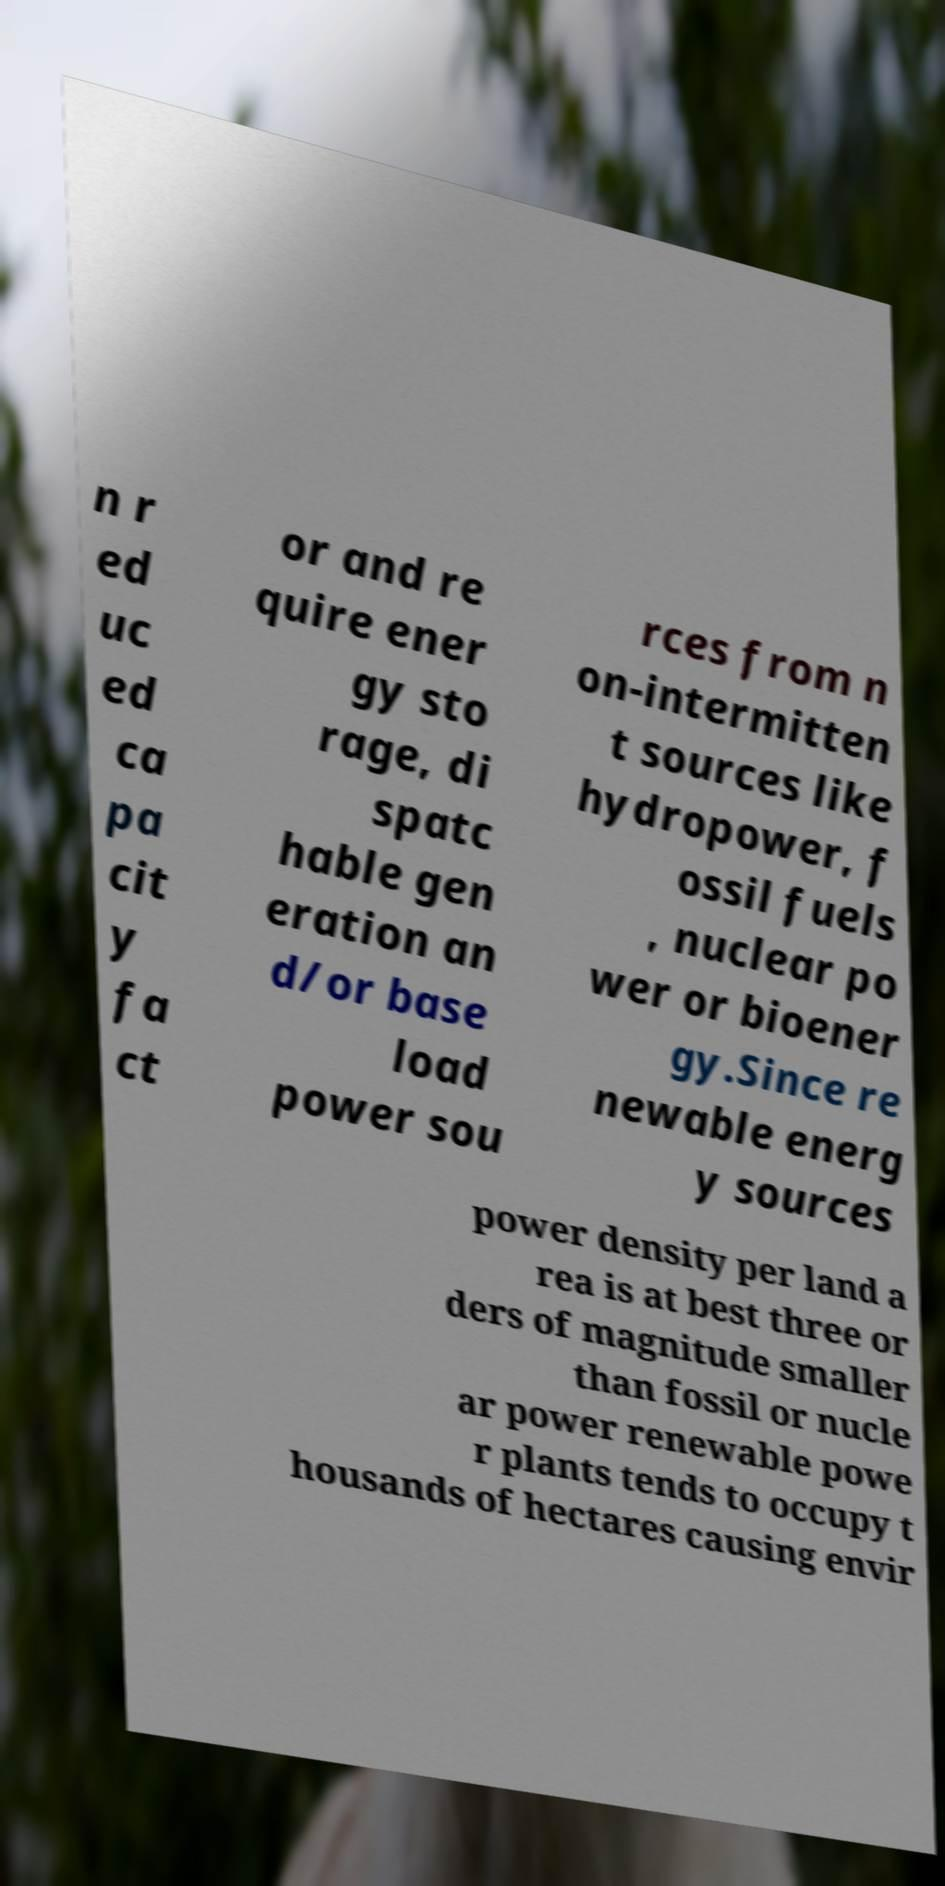There's text embedded in this image that I need extracted. Can you transcribe it verbatim? n r ed uc ed ca pa cit y fa ct or and re quire ener gy sto rage, di spatc hable gen eration an d/or base load power sou rces from n on-intermitten t sources like hydropower, f ossil fuels , nuclear po wer or bioener gy.Since re newable energ y sources power density per land a rea is at best three or ders of magnitude smaller than fossil or nucle ar power renewable powe r plants tends to occupy t housands of hectares causing envir 